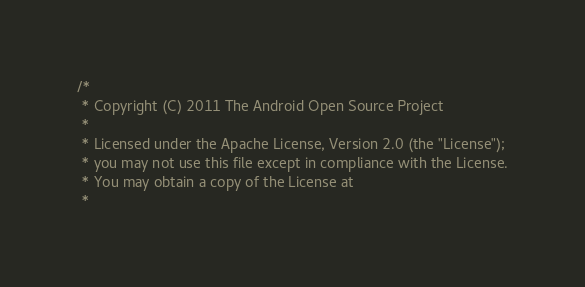<code> <loc_0><loc_0><loc_500><loc_500><_C_>/*
 * Copyright (C) 2011 The Android Open Source Project
 *
 * Licensed under the Apache License, Version 2.0 (the "License");
 * you may not use this file except in compliance with the License.
 * You may obtain a copy of the License at
 *</code> 